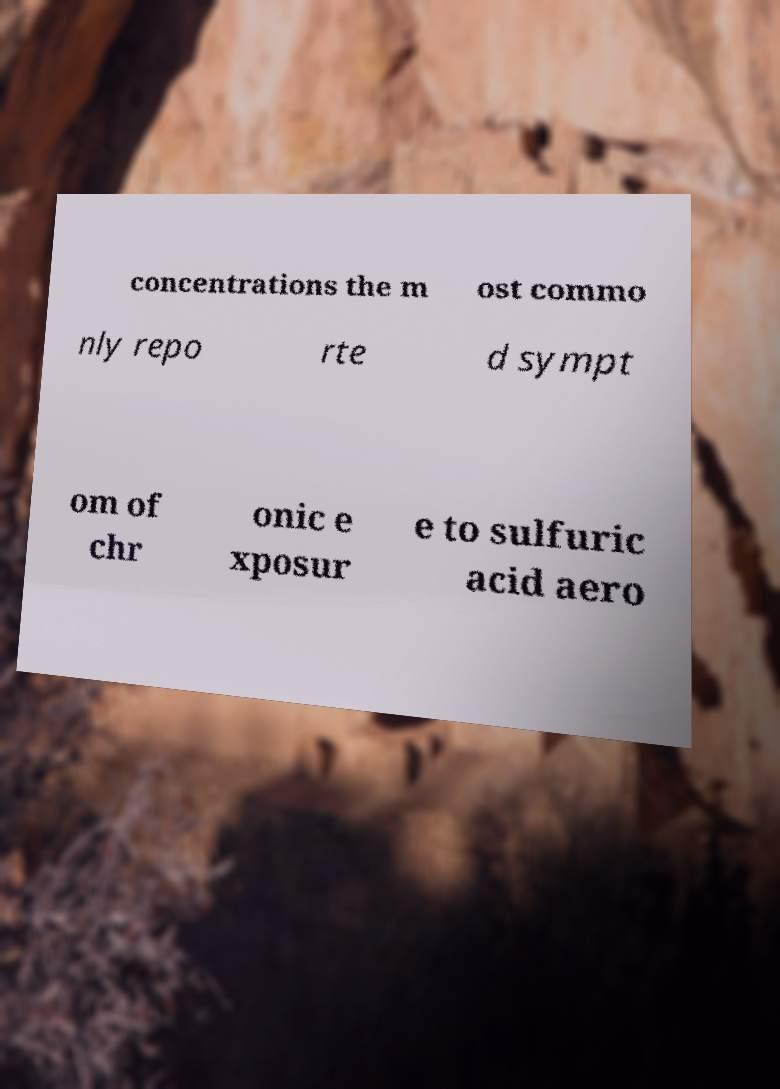Could you assist in decoding the text presented in this image and type it out clearly? concentrations the m ost commo nly repo rte d sympt om of chr onic e xposur e to sulfuric acid aero 